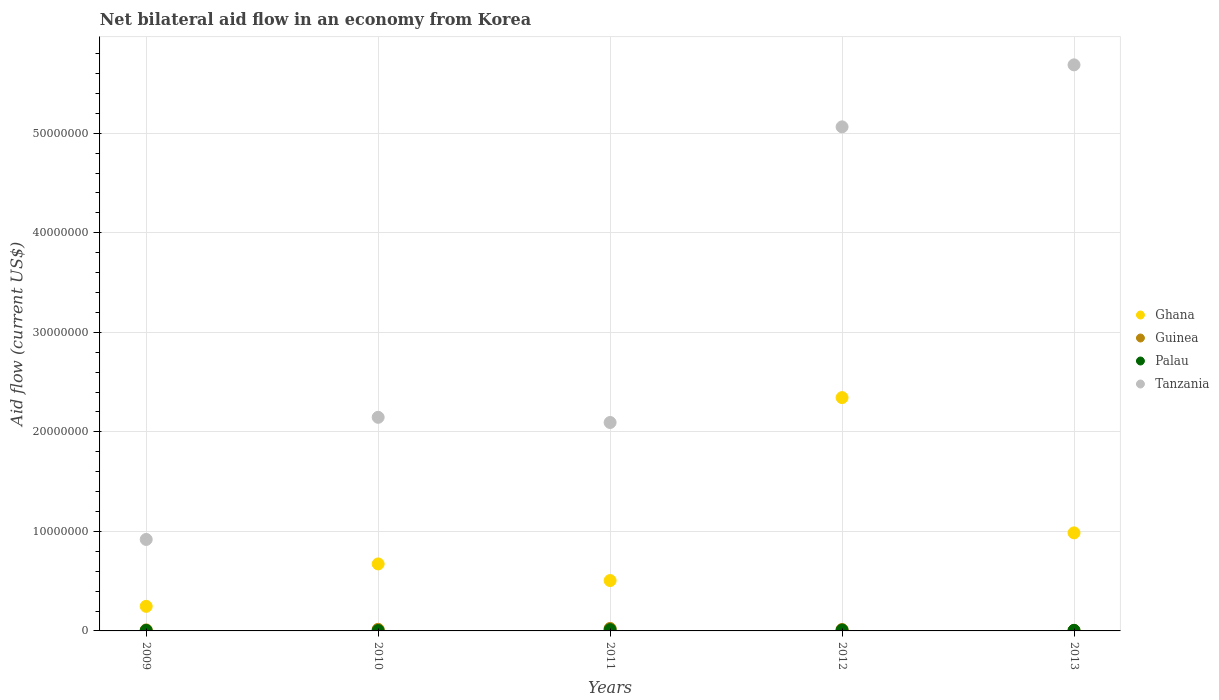How many different coloured dotlines are there?
Offer a very short reply. 4. What is the net bilateral aid flow in Tanzania in 2012?
Give a very brief answer. 5.06e+07. Across all years, what is the minimum net bilateral aid flow in Tanzania?
Keep it short and to the point. 9.19e+06. In which year was the net bilateral aid flow in Tanzania maximum?
Provide a succinct answer. 2013. What is the total net bilateral aid flow in Ghana in the graph?
Ensure brevity in your answer.  4.76e+07. What is the difference between the net bilateral aid flow in Ghana in 2012 and that in 2013?
Your answer should be compact. 1.36e+07. What is the difference between the net bilateral aid flow in Guinea in 2011 and the net bilateral aid flow in Ghana in 2009?
Offer a very short reply. -2.22e+06. What is the average net bilateral aid flow in Ghana per year?
Offer a terse response. 9.51e+06. In the year 2011, what is the difference between the net bilateral aid flow in Palau and net bilateral aid flow in Ghana?
Provide a short and direct response. -4.93e+06. In how many years, is the net bilateral aid flow in Ghana greater than 24000000 US$?
Provide a short and direct response. 0. What is the ratio of the net bilateral aid flow in Ghana in 2011 to that in 2012?
Offer a very short reply. 0.22. Is the net bilateral aid flow in Tanzania in 2011 less than that in 2012?
Provide a succinct answer. Yes. What is the difference between the highest and the second highest net bilateral aid flow in Tanzania?
Your answer should be very brief. 6.23e+06. What is the difference between the highest and the lowest net bilateral aid flow in Guinea?
Offer a very short reply. 2.00e+05. In how many years, is the net bilateral aid flow in Ghana greater than the average net bilateral aid flow in Ghana taken over all years?
Offer a very short reply. 2. Is the sum of the net bilateral aid flow in Ghana in 2012 and 2013 greater than the maximum net bilateral aid flow in Guinea across all years?
Ensure brevity in your answer.  Yes. Is the net bilateral aid flow in Guinea strictly less than the net bilateral aid flow in Palau over the years?
Your response must be concise. No. How many years are there in the graph?
Make the answer very short. 5. Does the graph contain grids?
Your answer should be compact. Yes. Where does the legend appear in the graph?
Offer a terse response. Center right. How many legend labels are there?
Offer a terse response. 4. How are the legend labels stacked?
Your response must be concise. Vertical. What is the title of the graph?
Ensure brevity in your answer.  Net bilateral aid flow in an economy from Korea. Does "Cyprus" appear as one of the legend labels in the graph?
Give a very brief answer. No. What is the label or title of the Y-axis?
Make the answer very short. Aid flow (current US$). What is the Aid flow (current US$) of Ghana in 2009?
Keep it short and to the point. 2.47e+06. What is the Aid flow (current US$) in Tanzania in 2009?
Provide a succinct answer. 9.19e+06. What is the Aid flow (current US$) in Ghana in 2010?
Provide a short and direct response. 6.73e+06. What is the Aid flow (current US$) of Tanzania in 2010?
Your answer should be very brief. 2.15e+07. What is the Aid flow (current US$) in Ghana in 2011?
Offer a terse response. 5.06e+06. What is the Aid flow (current US$) of Guinea in 2011?
Your answer should be compact. 2.50e+05. What is the Aid flow (current US$) in Tanzania in 2011?
Keep it short and to the point. 2.09e+07. What is the Aid flow (current US$) of Ghana in 2012?
Offer a terse response. 2.34e+07. What is the Aid flow (current US$) in Guinea in 2012?
Offer a very short reply. 1.40e+05. What is the Aid flow (current US$) in Tanzania in 2012?
Provide a short and direct response. 5.06e+07. What is the Aid flow (current US$) of Ghana in 2013?
Your answer should be very brief. 9.85e+06. What is the Aid flow (current US$) of Guinea in 2013?
Ensure brevity in your answer.  5.00e+04. What is the Aid flow (current US$) in Tanzania in 2013?
Your response must be concise. 5.69e+07. Across all years, what is the maximum Aid flow (current US$) of Ghana?
Provide a succinct answer. 2.34e+07. Across all years, what is the maximum Aid flow (current US$) in Tanzania?
Ensure brevity in your answer.  5.69e+07. Across all years, what is the minimum Aid flow (current US$) in Ghana?
Keep it short and to the point. 2.47e+06. Across all years, what is the minimum Aid flow (current US$) of Tanzania?
Offer a terse response. 9.19e+06. What is the total Aid flow (current US$) in Ghana in the graph?
Provide a succinct answer. 4.76e+07. What is the total Aid flow (current US$) of Guinea in the graph?
Your answer should be compact. 7.00e+05. What is the total Aid flow (current US$) in Palau in the graph?
Provide a short and direct response. 3.70e+05. What is the total Aid flow (current US$) of Tanzania in the graph?
Give a very brief answer. 1.59e+08. What is the difference between the Aid flow (current US$) in Ghana in 2009 and that in 2010?
Your response must be concise. -4.26e+06. What is the difference between the Aid flow (current US$) in Tanzania in 2009 and that in 2010?
Provide a succinct answer. -1.23e+07. What is the difference between the Aid flow (current US$) in Ghana in 2009 and that in 2011?
Keep it short and to the point. -2.59e+06. What is the difference between the Aid flow (current US$) of Guinea in 2009 and that in 2011?
Your response must be concise. -1.50e+05. What is the difference between the Aid flow (current US$) of Palau in 2009 and that in 2011?
Your answer should be very brief. -8.00e+04. What is the difference between the Aid flow (current US$) in Tanzania in 2009 and that in 2011?
Offer a terse response. -1.18e+07. What is the difference between the Aid flow (current US$) in Ghana in 2009 and that in 2012?
Give a very brief answer. -2.10e+07. What is the difference between the Aid flow (current US$) of Guinea in 2009 and that in 2012?
Provide a succinct answer. -4.00e+04. What is the difference between the Aid flow (current US$) in Palau in 2009 and that in 2012?
Your response must be concise. -4.00e+04. What is the difference between the Aid flow (current US$) of Tanzania in 2009 and that in 2012?
Give a very brief answer. -4.14e+07. What is the difference between the Aid flow (current US$) in Ghana in 2009 and that in 2013?
Ensure brevity in your answer.  -7.38e+06. What is the difference between the Aid flow (current US$) in Guinea in 2009 and that in 2013?
Your answer should be very brief. 5.00e+04. What is the difference between the Aid flow (current US$) of Palau in 2009 and that in 2013?
Offer a terse response. -10000. What is the difference between the Aid flow (current US$) of Tanzania in 2009 and that in 2013?
Keep it short and to the point. -4.77e+07. What is the difference between the Aid flow (current US$) in Ghana in 2010 and that in 2011?
Provide a short and direct response. 1.67e+06. What is the difference between the Aid flow (current US$) of Guinea in 2010 and that in 2011?
Your answer should be very brief. -9.00e+04. What is the difference between the Aid flow (current US$) of Tanzania in 2010 and that in 2011?
Give a very brief answer. 5.20e+05. What is the difference between the Aid flow (current US$) of Ghana in 2010 and that in 2012?
Give a very brief answer. -1.67e+07. What is the difference between the Aid flow (current US$) of Palau in 2010 and that in 2012?
Offer a very short reply. -5.00e+04. What is the difference between the Aid flow (current US$) in Tanzania in 2010 and that in 2012?
Provide a short and direct response. -2.92e+07. What is the difference between the Aid flow (current US$) in Ghana in 2010 and that in 2013?
Ensure brevity in your answer.  -3.12e+06. What is the difference between the Aid flow (current US$) in Tanzania in 2010 and that in 2013?
Give a very brief answer. -3.54e+07. What is the difference between the Aid flow (current US$) of Ghana in 2011 and that in 2012?
Ensure brevity in your answer.  -1.84e+07. What is the difference between the Aid flow (current US$) of Guinea in 2011 and that in 2012?
Give a very brief answer. 1.10e+05. What is the difference between the Aid flow (current US$) of Palau in 2011 and that in 2012?
Your response must be concise. 4.00e+04. What is the difference between the Aid flow (current US$) of Tanzania in 2011 and that in 2012?
Make the answer very short. -2.97e+07. What is the difference between the Aid flow (current US$) of Ghana in 2011 and that in 2013?
Provide a short and direct response. -4.79e+06. What is the difference between the Aid flow (current US$) in Guinea in 2011 and that in 2013?
Your response must be concise. 2.00e+05. What is the difference between the Aid flow (current US$) in Palau in 2011 and that in 2013?
Offer a very short reply. 7.00e+04. What is the difference between the Aid flow (current US$) of Tanzania in 2011 and that in 2013?
Offer a terse response. -3.59e+07. What is the difference between the Aid flow (current US$) of Ghana in 2012 and that in 2013?
Make the answer very short. 1.36e+07. What is the difference between the Aid flow (current US$) in Tanzania in 2012 and that in 2013?
Offer a very short reply. -6.23e+06. What is the difference between the Aid flow (current US$) in Ghana in 2009 and the Aid flow (current US$) in Guinea in 2010?
Offer a very short reply. 2.31e+06. What is the difference between the Aid flow (current US$) of Ghana in 2009 and the Aid flow (current US$) of Palau in 2010?
Give a very brief answer. 2.43e+06. What is the difference between the Aid flow (current US$) in Ghana in 2009 and the Aid flow (current US$) in Tanzania in 2010?
Provide a succinct answer. -1.90e+07. What is the difference between the Aid flow (current US$) of Guinea in 2009 and the Aid flow (current US$) of Palau in 2010?
Make the answer very short. 6.00e+04. What is the difference between the Aid flow (current US$) of Guinea in 2009 and the Aid flow (current US$) of Tanzania in 2010?
Offer a terse response. -2.14e+07. What is the difference between the Aid flow (current US$) of Palau in 2009 and the Aid flow (current US$) of Tanzania in 2010?
Ensure brevity in your answer.  -2.14e+07. What is the difference between the Aid flow (current US$) of Ghana in 2009 and the Aid flow (current US$) of Guinea in 2011?
Your answer should be compact. 2.22e+06. What is the difference between the Aid flow (current US$) of Ghana in 2009 and the Aid flow (current US$) of Palau in 2011?
Your response must be concise. 2.34e+06. What is the difference between the Aid flow (current US$) of Ghana in 2009 and the Aid flow (current US$) of Tanzania in 2011?
Provide a succinct answer. -1.85e+07. What is the difference between the Aid flow (current US$) in Guinea in 2009 and the Aid flow (current US$) in Palau in 2011?
Keep it short and to the point. -3.00e+04. What is the difference between the Aid flow (current US$) in Guinea in 2009 and the Aid flow (current US$) in Tanzania in 2011?
Make the answer very short. -2.08e+07. What is the difference between the Aid flow (current US$) of Palau in 2009 and the Aid flow (current US$) of Tanzania in 2011?
Offer a very short reply. -2.09e+07. What is the difference between the Aid flow (current US$) of Ghana in 2009 and the Aid flow (current US$) of Guinea in 2012?
Offer a terse response. 2.33e+06. What is the difference between the Aid flow (current US$) in Ghana in 2009 and the Aid flow (current US$) in Palau in 2012?
Offer a terse response. 2.38e+06. What is the difference between the Aid flow (current US$) of Ghana in 2009 and the Aid flow (current US$) of Tanzania in 2012?
Offer a very short reply. -4.82e+07. What is the difference between the Aid flow (current US$) in Guinea in 2009 and the Aid flow (current US$) in Palau in 2012?
Offer a terse response. 10000. What is the difference between the Aid flow (current US$) of Guinea in 2009 and the Aid flow (current US$) of Tanzania in 2012?
Offer a very short reply. -5.05e+07. What is the difference between the Aid flow (current US$) of Palau in 2009 and the Aid flow (current US$) of Tanzania in 2012?
Your answer should be very brief. -5.06e+07. What is the difference between the Aid flow (current US$) in Ghana in 2009 and the Aid flow (current US$) in Guinea in 2013?
Offer a terse response. 2.42e+06. What is the difference between the Aid flow (current US$) in Ghana in 2009 and the Aid flow (current US$) in Palau in 2013?
Your response must be concise. 2.41e+06. What is the difference between the Aid flow (current US$) of Ghana in 2009 and the Aid flow (current US$) of Tanzania in 2013?
Your answer should be very brief. -5.44e+07. What is the difference between the Aid flow (current US$) of Guinea in 2009 and the Aid flow (current US$) of Tanzania in 2013?
Give a very brief answer. -5.68e+07. What is the difference between the Aid flow (current US$) in Palau in 2009 and the Aid flow (current US$) in Tanzania in 2013?
Make the answer very short. -5.68e+07. What is the difference between the Aid flow (current US$) of Ghana in 2010 and the Aid flow (current US$) of Guinea in 2011?
Offer a very short reply. 6.48e+06. What is the difference between the Aid flow (current US$) of Ghana in 2010 and the Aid flow (current US$) of Palau in 2011?
Provide a short and direct response. 6.60e+06. What is the difference between the Aid flow (current US$) in Ghana in 2010 and the Aid flow (current US$) in Tanzania in 2011?
Ensure brevity in your answer.  -1.42e+07. What is the difference between the Aid flow (current US$) in Guinea in 2010 and the Aid flow (current US$) in Tanzania in 2011?
Offer a terse response. -2.08e+07. What is the difference between the Aid flow (current US$) in Palau in 2010 and the Aid flow (current US$) in Tanzania in 2011?
Make the answer very short. -2.09e+07. What is the difference between the Aid flow (current US$) in Ghana in 2010 and the Aid flow (current US$) in Guinea in 2012?
Ensure brevity in your answer.  6.59e+06. What is the difference between the Aid flow (current US$) in Ghana in 2010 and the Aid flow (current US$) in Palau in 2012?
Keep it short and to the point. 6.64e+06. What is the difference between the Aid flow (current US$) in Ghana in 2010 and the Aid flow (current US$) in Tanzania in 2012?
Make the answer very short. -4.39e+07. What is the difference between the Aid flow (current US$) of Guinea in 2010 and the Aid flow (current US$) of Tanzania in 2012?
Give a very brief answer. -5.05e+07. What is the difference between the Aid flow (current US$) in Palau in 2010 and the Aid flow (current US$) in Tanzania in 2012?
Provide a short and direct response. -5.06e+07. What is the difference between the Aid flow (current US$) in Ghana in 2010 and the Aid flow (current US$) in Guinea in 2013?
Your answer should be very brief. 6.68e+06. What is the difference between the Aid flow (current US$) of Ghana in 2010 and the Aid flow (current US$) of Palau in 2013?
Offer a very short reply. 6.67e+06. What is the difference between the Aid flow (current US$) in Ghana in 2010 and the Aid flow (current US$) in Tanzania in 2013?
Offer a very short reply. -5.01e+07. What is the difference between the Aid flow (current US$) in Guinea in 2010 and the Aid flow (current US$) in Tanzania in 2013?
Ensure brevity in your answer.  -5.67e+07. What is the difference between the Aid flow (current US$) in Palau in 2010 and the Aid flow (current US$) in Tanzania in 2013?
Offer a terse response. -5.68e+07. What is the difference between the Aid flow (current US$) of Ghana in 2011 and the Aid flow (current US$) of Guinea in 2012?
Give a very brief answer. 4.92e+06. What is the difference between the Aid flow (current US$) in Ghana in 2011 and the Aid flow (current US$) in Palau in 2012?
Keep it short and to the point. 4.97e+06. What is the difference between the Aid flow (current US$) in Ghana in 2011 and the Aid flow (current US$) in Tanzania in 2012?
Make the answer very short. -4.56e+07. What is the difference between the Aid flow (current US$) in Guinea in 2011 and the Aid flow (current US$) in Palau in 2012?
Your answer should be very brief. 1.60e+05. What is the difference between the Aid flow (current US$) in Guinea in 2011 and the Aid flow (current US$) in Tanzania in 2012?
Keep it short and to the point. -5.04e+07. What is the difference between the Aid flow (current US$) in Palau in 2011 and the Aid flow (current US$) in Tanzania in 2012?
Offer a terse response. -5.05e+07. What is the difference between the Aid flow (current US$) of Ghana in 2011 and the Aid flow (current US$) of Guinea in 2013?
Offer a very short reply. 5.01e+06. What is the difference between the Aid flow (current US$) in Ghana in 2011 and the Aid flow (current US$) in Palau in 2013?
Offer a very short reply. 5.00e+06. What is the difference between the Aid flow (current US$) in Ghana in 2011 and the Aid flow (current US$) in Tanzania in 2013?
Your answer should be very brief. -5.18e+07. What is the difference between the Aid flow (current US$) in Guinea in 2011 and the Aid flow (current US$) in Tanzania in 2013?
Your answer should be very brief. -5.66e+07. What is the difference between the Aid flow (current US$) of Palau in 2011 and the Aid flow (current US$) of Tanzania in 2013?
Ensure brevity in your answer.  -5.67e+07. What is the difference between the Aid flow (current US$) in Ghana in 2012 and the Aid flow (current US$) in Guinea in 2013?
Keep it short and to the point. 2.34e+07. What is the difference between the Aid flow (current US$) of Ghana in 2012 and the Aid flow (current US$) of Palau in 2013?
Your answer should be compact. 2.34e+07. What is the difference between the Aid flow (current US$) of Ghana in 2012 and the Aid flow (current US$) of Tanzania in 2013?
Provide a short and direct response. -3.34e+07. What is the difference between the Aid flow (current US$) in Guinea in 2012 and the Aid flow (current US$) in Palau in 2013?
Provide a short and direct response. 8.00e+04. What is the difference between the Aid flow (current US$) in Guinea in 2012 and the Aid flow (current US$) in Tanzania in 2013?
Ensure brevity in your answer.  -5.67e+07. What is the difference between the Aid flow (current US$) in Palau in 2012 and the Aid flow (current US$) in Tanzania in 2013?
Your answer should be very brief. -5.68e+07. What is the average Aid flow (current US$) in Ghana per year?
Your answer should be very brief. 9.51e+06. What is the average Aid flow (current US$) in Guinea per year?
Offer a terse response. 1.40e+05. What is the average Aid flow (current US$) of Palau per year?
Ensure brevity in your answer.  7.40e+04. What is the average Aid flow (current US$) in Tanzania per year?
Your response must be concise. 3.18e+07. In the year 2009, what is the difference between the Aid flow (current US$) of Ghana and Aid flow (current US$) of Guinea?
Keep it short and to the point. 2.37e+06. In the year 2009, what is the difference between the Aid flow (current US$) in Ghana and Aid flow (current US$) in Palau?
Give a very brief answer. 2.42e+06. In the year 2009, what is the difference between the Aid flow (current US$) in Ghana and Aid flow (current US$) in Tanzania?
Give a very brief answer. -6.72e+06. In the year 2009, what is the difference between the Aid flow (current US$) in Guinea and Aid flow (current US$) in Tanzania?
Your response must be concise. -9.09e+06. In the year 2009, what is the difference between the Aid flow (current US$) of Palau and Aid flow (current US$) of Tanzania?
Offer a very short reply. -9.14e+06. In the year 2010, what is the difference between the Aid flow (current US$) of Ghana and Aid flow (current US$) of Guinea?
Keep it short and to the point. 6.57e+06. In the year 2010, what is the difference between the Aid flow (current US$) in Ghana and Aid flow (current US$) in Palau?
Your response must be concise. 6.69e+06. In the year 2010, what is the difference between the Aid flow (current US$) of Ghana and Aid flow (current US$) of Tanzania?
Make the answer very short. -1.47e+07. In the year 2010, what is the difference between the Aid flow (current US$) in Guinea and Aid flow (current US$) in Tanzania?
Give a very brief answer. -2.13e+07. In the year 2010, what is the difference between the Aid flow (current US$) of Palau and Aid flow (current US$) of Tanzania?
Your answer should be very brief. -2.14e+07. In the year 2011, what is the difference between the Aid flow (current US$) in Ghana and Aid flow (current US$) in Guinea?
Your answer should be very brief. 4.81e+06. In the year 2011, what is the difference between the Aid flow (current US$) in Ghana and Aid flow (current US$) in Palau?
Ensure brevity in your answer.  4.93e+06. In the year 2011, what is the difference between the Aid flow (current US$) of Ghana and Aid flow (current US$) of Tanzania?
Your response must be concise. -1.59e+07. In the year 2011, what is the difference between the Aid flow (current US$) of Guinea and Aid flow (current US$) of Palau?
Provide a short and direct response. 1.20e+05. In the year 2011, what is the difference between the Aid flow (current US$) in Guinea and Aid flow (current US$) in Tanzania?
Your answer should be compact. -2.07e+07. In the year 2011, what is the difference between the Aid flow (current US$) in Palau and Aid flow (current US$) in Tanzania?
Keep it short and to the point. -2.08e+07. In the year 2012, what is the difference between the Aid flow (current US$) in Ghana and Aid flow (current US$) in Guinea?
Offer a terse response. 2.33e+07. In the year 2012, what is the difference between the Aid flow (current US$) in Ghana and Aid flow (current US$) in Palau?
Provide a succinct answer. 2.34e+07. In the year 2012, what is the difference between the Aid flow (current US$) in Ghana and Aid flow (current US$) in Tanzania?
Provide a succinct answer. -2.72e+07. In the year 2012, what is the difference between the Aid flow (current US$) of Guinea and Aid flow (current US$) of Palau?
Ensure brevity in your answer.  5.00e+04. In the year 2012, what is the difference between the Aid flow (current US$) in Guinea and Aid flow (current US$) in Tanzania?
Keep it short and to the point. -5.05e+07. In the year 2012, what is the difference between the Aid flow (current US$) in Palau and Aid flow (current US$) in Tanzania?
Your response must be concise. -5.06e+07. In the year 2013, what is the difference between the Aid flow (current US$) of Ghana and Aid flow (current US$) of Guinea?
Your answer should be very brief. 9.80e+06. In the year 2013, what is the difference between the Aid flow (current US$) of Ghana and Aid flow (current US$) of Palau?
Offer a terse response. 9.79e+06. In the year 2013, what is the difference between the Aid flow (current US$) of Ghana and Aid flow (current US$) of Tanzania?
Offer a very short reply. -4.70e+07. In the year 2013, what is the difference between the Aid flow (current US$) in Guinea and Aid flow (current US$) in Palau?
Ensure brevity in your answer.  -10000. In the year 2013, what is the difference between the Aid flow (current US$) of Guinea and Aid flow (current US$) of Tanzania?
Your answer should be compact. -5.68e+07. In the year 2013, what is the difference between the Aid flow (current US$) in Palau and Aid flow (current US$) in Tanzania?
Keep it short and to the point. -5.68e+07. What is the ratio of the Aid flow (current US$) of Ghana in 2009 to that in 2010?
Your response must be concise. 0.37. What is the ratio of the Aid flow (current US$) in Guinea in 2009 to that in 2010?
Provide a short and direct response. 0.62. What is the ratio of the Aid flow (current US$) of Palau in 2009 to that in 2010?
Offer a very short reply. 1.25. What is the ratio of the Aid flow (current US$) of Tanzania in 2009 to that in 2010?
Your answer should be very brief. 0.43. What is the ratio of the Aid flow (current US$) in Ghana in 2009 to that in 2011?
Give a very brief answer. 0.49. What is the ratio of the Aid flow (current US$) of Guinea in 2009 to that in 2011?
Ensure brevity in your answer.  0.4. What is the ratio of the Aid flow (current US$) in Palau in 2009 to that in 2011?
Your answer should be very brief. 0.38. What is the ratio of the Aid flow (current US$) of Tanzania in 2009 to that in 2011?
Provide a short and direct response. 0.44. What is the ratio of the Aid flow (current US$) of Ghana in 2009 to that in 2012?
Offer a terse response. 0.11. What is the ratio of the Aid flow (current US$) of Palau in 2009 to that in 2012?
Provide a short and direct response. 0.56. What is the ratio of the Aid flow (current US$) of Tanzania in 2009 to that in 2012?
Make the answer very short. 0.18. What is the ratio of the Aid flow (current US$) in Ghana in 2009 to that in 2013?
Your answer should be compact. 0.25. What is the ratio of the Aid flow (current US$) of Palau in 2009 to that in 2013?
Offer a very short reply. 0.83. What is the ratio of the Aid flow (current US$) of Tanzania in 2009 to that in 2013?
Offer a very short reply. 0.16. What is the ratio of the Aid flow (current US$) in Ghana in 2010 to that in 2011?
Your answer should be compact. 1.33. What is the ratio of the Aid flow (current US$) in Guinea in 2010 to that in 2011?
Your answer should be compact. 0.64. What is the ratio of the Aid flow (current US$) in Palau in 2010 to that in 2011?
Offer a terse response. 0.31. What is the ratio of the Aid flow (current US$) in Tanzania in 2010 to that in 2011?
Offer a terse response. 1.02. What is the ratio of the Aid flow (current US$) in Ghana in 2010 to that in 2012?
Your answer should be very brief. 0.29. What is the ratio of the Aid flow (current US$) in Palau in 2010 to that in 2012?
Provide a short and direct response. 0.44. What is the ratio of the Aid flow (current US$) in Tanzania in 2010 to that in 2012?
Your answer should be very brief. 0.42. What is the ratio of the Aid flow (current US$) in Ghana in 2010 to that in 2013?
Your answer should be compact. 0.68. What is the ratio of the Aid flow (current US$) of Guinea in 2010 to that in 2013?
Provide a short and direct response. 3.2. What is the ratio of the Aid flow (current US$) of Palau in 2010 to that in 2013?
Provide a succinct answer. 0.67. What is the ratio of the Aid flow (current US$) of Tanzania in 2010 to that in 2013?
Provide a succinct answer. 0.38. What is the ratio of the Aid flow (current US$) of Ghana in 2011 to that in 2012?
Provide a short and direct response. 0.22. What is the ratio of the Aid flow (current US$) of Guinea in 2011 to that in 2012?
Provide a short and direct response. 1.79. What is the ratio of the Aid flow (current US$) of Palau in 2011 to that in 2012?
Offer a terse response. 1.44. What is the ratio of the Aid flow (current US$) in Tanzania in 2011 to that in 2012?
Your answer should be very brief. 0.41. What is the ratio of the Aid flow (current US$) of Ghana in 2011 to that in 2013?
Ensure brevity in your answer.  0.51. What is the ratio of the Aid flow (current US$) in Guinea in 2011 to that in 2013?
Ensure brevity in your answer.  5. What is the ratio of the Aid flow (current US$) of Palau in 2011 to that in 2013?
Give a very brief answer. 2.17. What is the ratio of the Aid flow (current US$) in Tanzania in 2011 to that in 2013?
Make the answer very short. 0.37. What is the ratio of the Aid flow (current US$) in Ghana in 2012 to that in 2013?
Make the answer very short. 2.38. What is the ratio of the Aid flow (current US$) of Tanzania in 2012 to that in 2013?
Make the answer very short. 0.89. What is the difference between the highest and the second highest Aid flow (current US$) of Ghana?
Offer a very short reply. 1.36e+07. What is the difference between the highest and the second highest Aid flow (current US$) in Guinea?
Offer a terse response. 9.00e+04. What is the difference between the highest and the second highest Aid flow (current US$) of Palau?
Ensure brevity in your answer.  4.00e+04. What is the difference between the highest and the second highest Aid flow (current US$) of Tanzania?
Make the answer very short. 6.23e+06. What is the difference between the highest and the lowest Aid flow (current US$) in Ghana?
Ensure brevity in your answer.  2.10e+07. What is the difference between the highest and the lowest Aid flow (current US$) in Palau?
Provide a succinct answer. 9.00e+04. What is the difference between the highest and the lowest Aid flow (current US$) in Tanzania?
Your answer should be compact. 4.77e+07. 